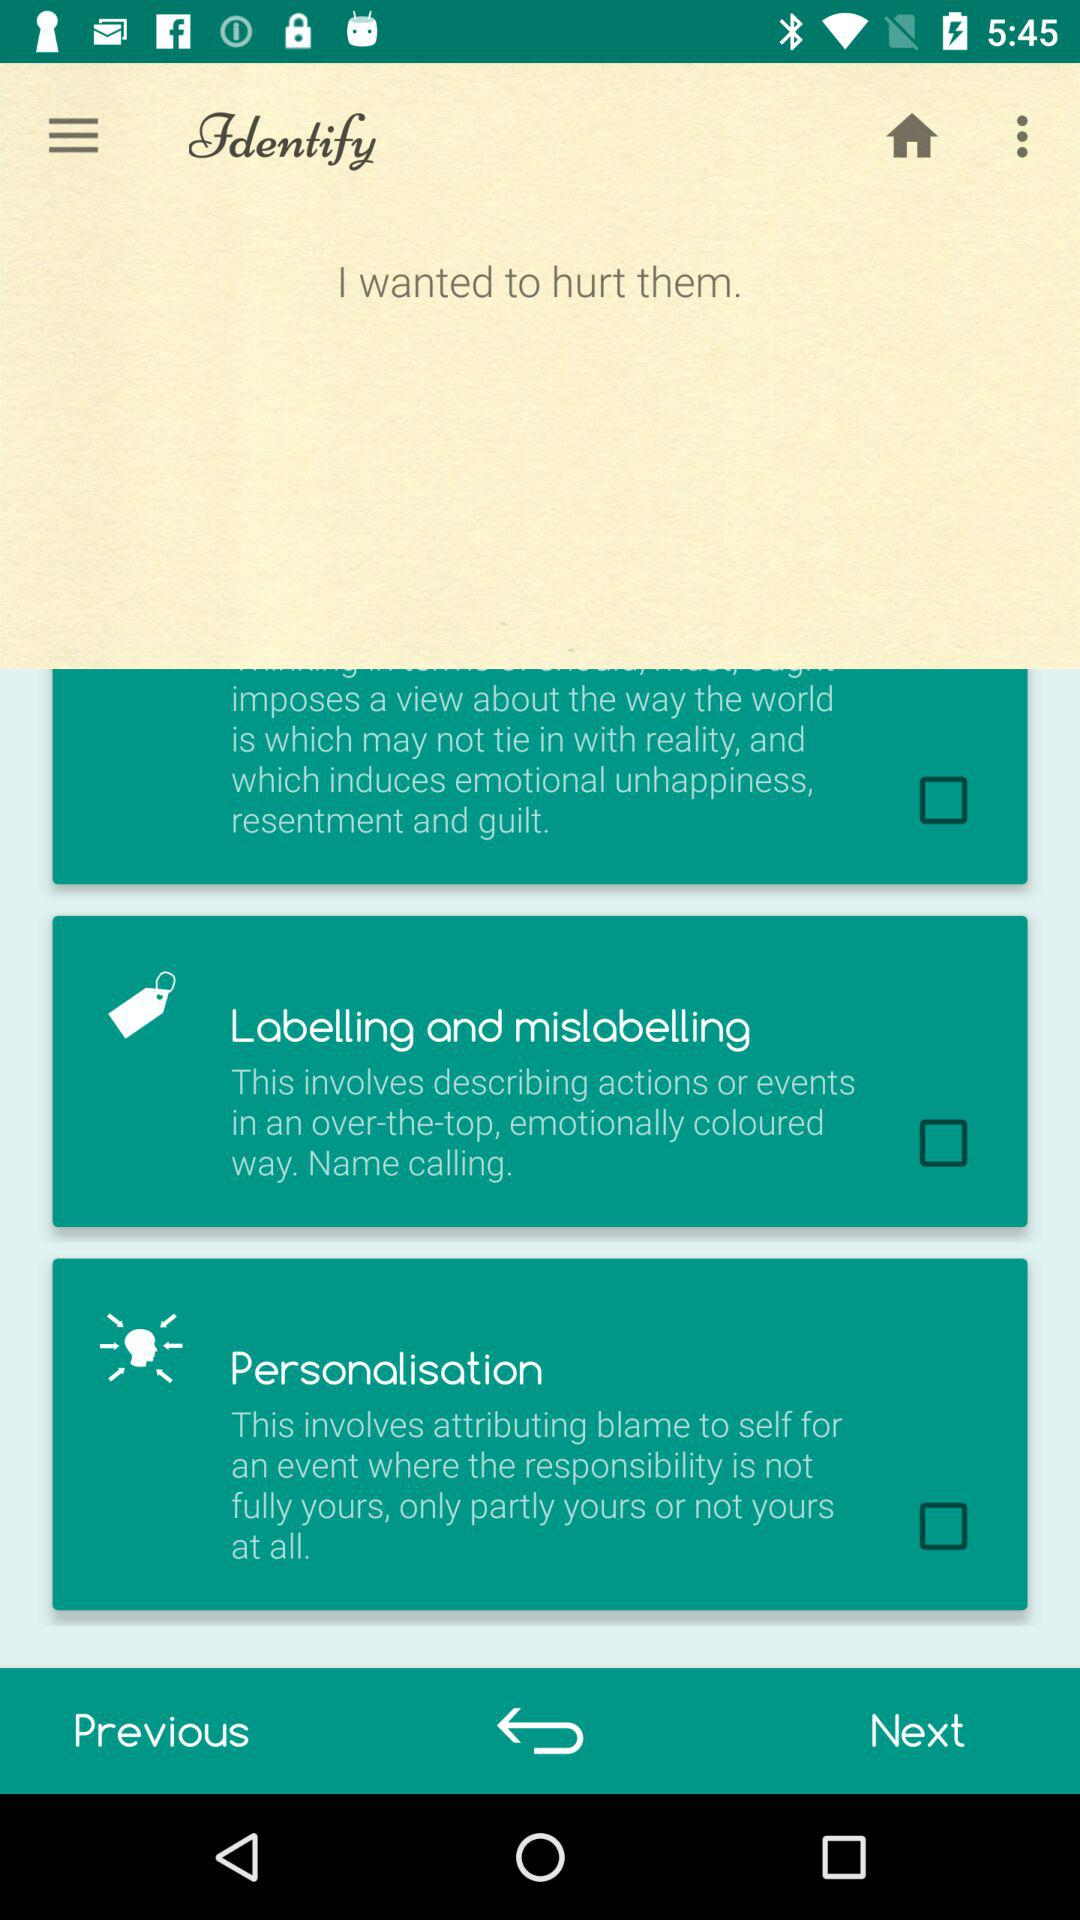How many unread messages are there?
When the provided information is insufficient, respond with <no answer>. <no answer> 